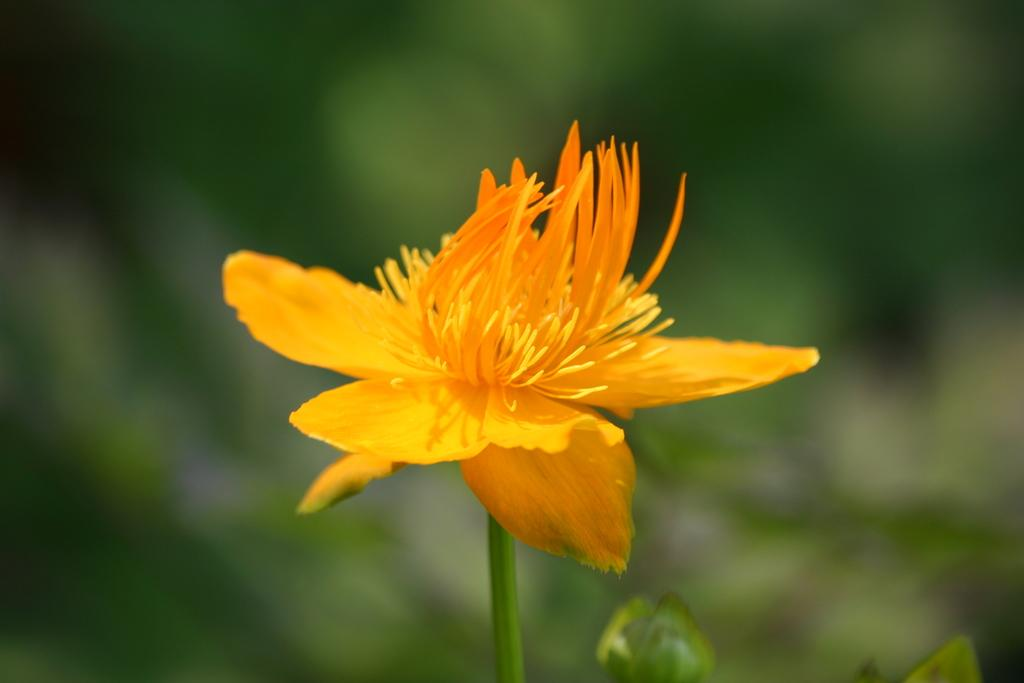What is the main subject of the image? The main subject of the image is a flower with a stem. Can you describe the background of the image? The background of the image is blurred. What type of steel is used to create the blade in the image? There is no steel or blade present in the image; it features a flower with a stem and a blurred background. 